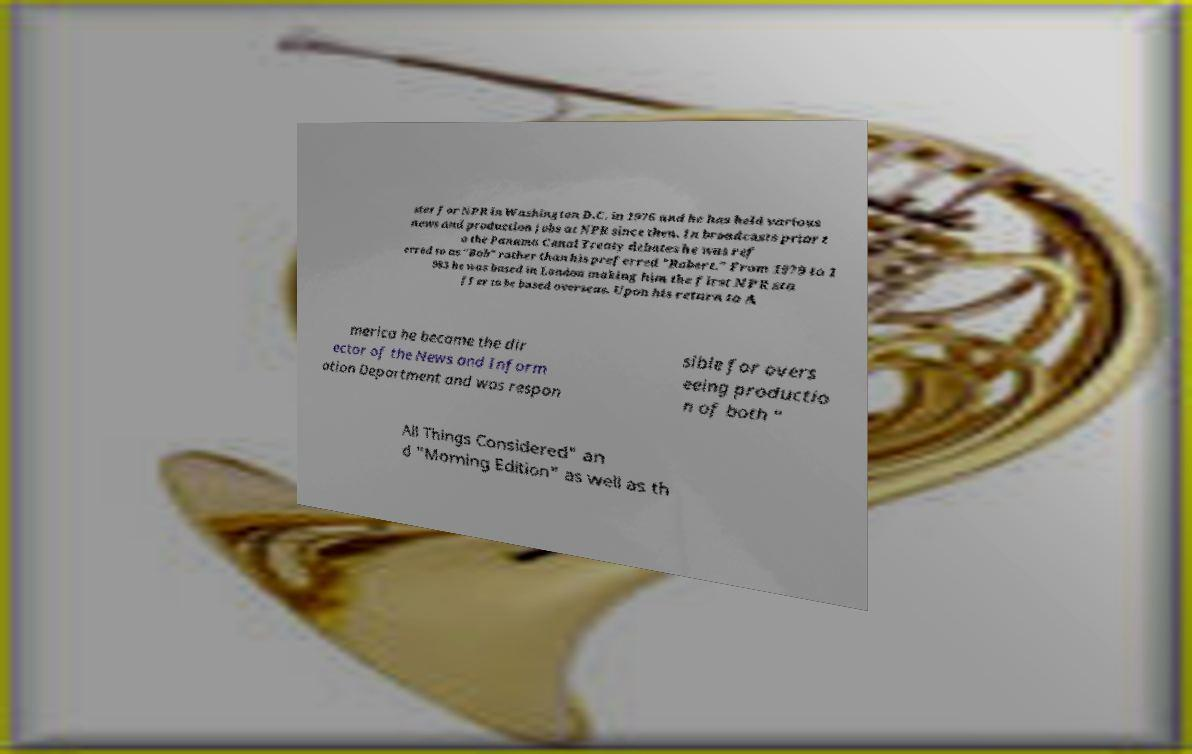Can you accurately transcribe the text from the provided image for me? ster for NPR in Washington D.C. in 1976 and he has held various news and production jobs at NPR since then. In broadcasts prior t o the Panama Canal Treaty debates he was ref erred to as "Bob" rather than his preferred "Robert." From 1979 to 1 983 he was based in London making him the first NPR sta ffer to be based overseas. Upon his return to A merica he became the dir ector of the News and Inform ation Department and was respon sible for overs eeing productio n of both " All Things Considered" an d "Morning Edition" as well as th 